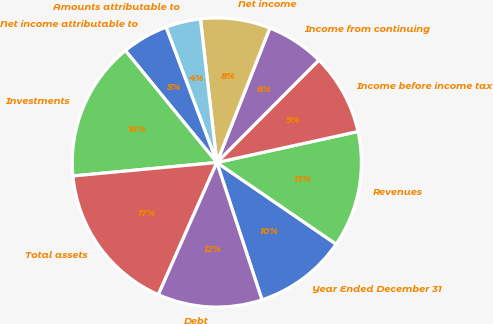<chart> <loc_0><loc_0><loc_500><loc_500><pie_chart><fcel>Year Ended December 31<fcel>Revenues<fcel>Income before income tax<fcel>Income from continuing<fcel>Net income<fcel>Amounts attributable to<fcel>Net income attributable to<fcel>Investments<fcel>Total assets<fcel>Debt<nl><fcel>10.39%<fcel>12.99%<fcel>9.09%<fcel>6.49%<fcel>7.79%<fcel>3.9%<fcel>5.19%<fcel>15.58%<fcel>16.88%<fcel>11.69%<nl></chart> 